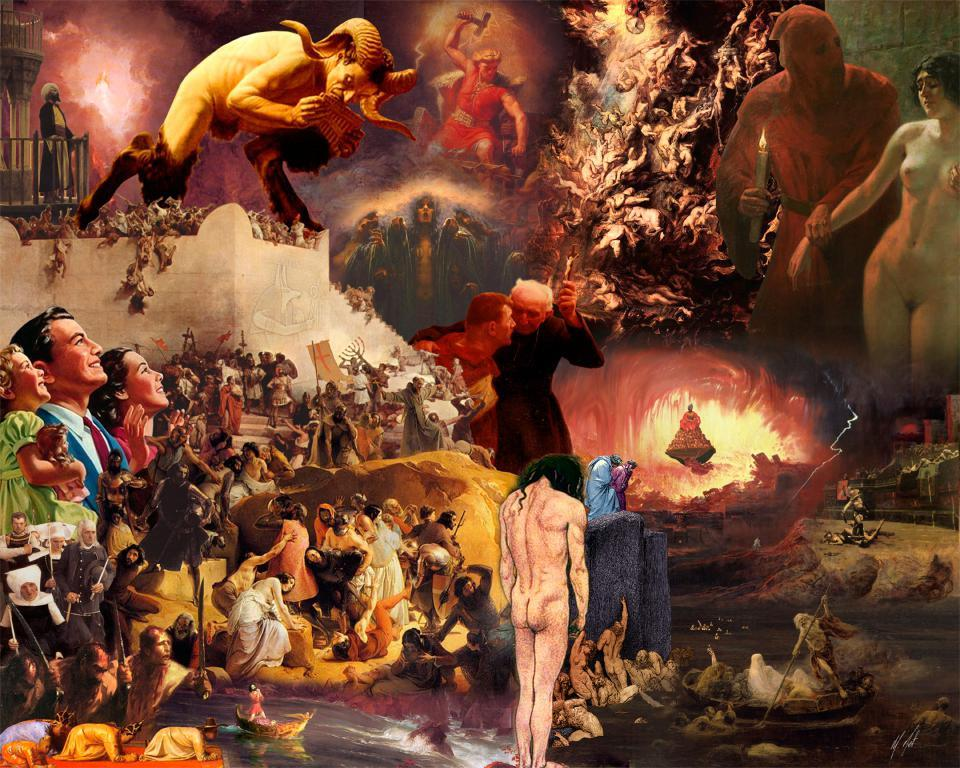What type of art is shown in the image? The image appears to be an art piece that resembles a painting. How many people are depicted in the painting? There are many people depicted in the painting. What types of toys can be seen in the hands of the children in the image? There are no children or toys present in the image; it is a painting with many people depicted. 